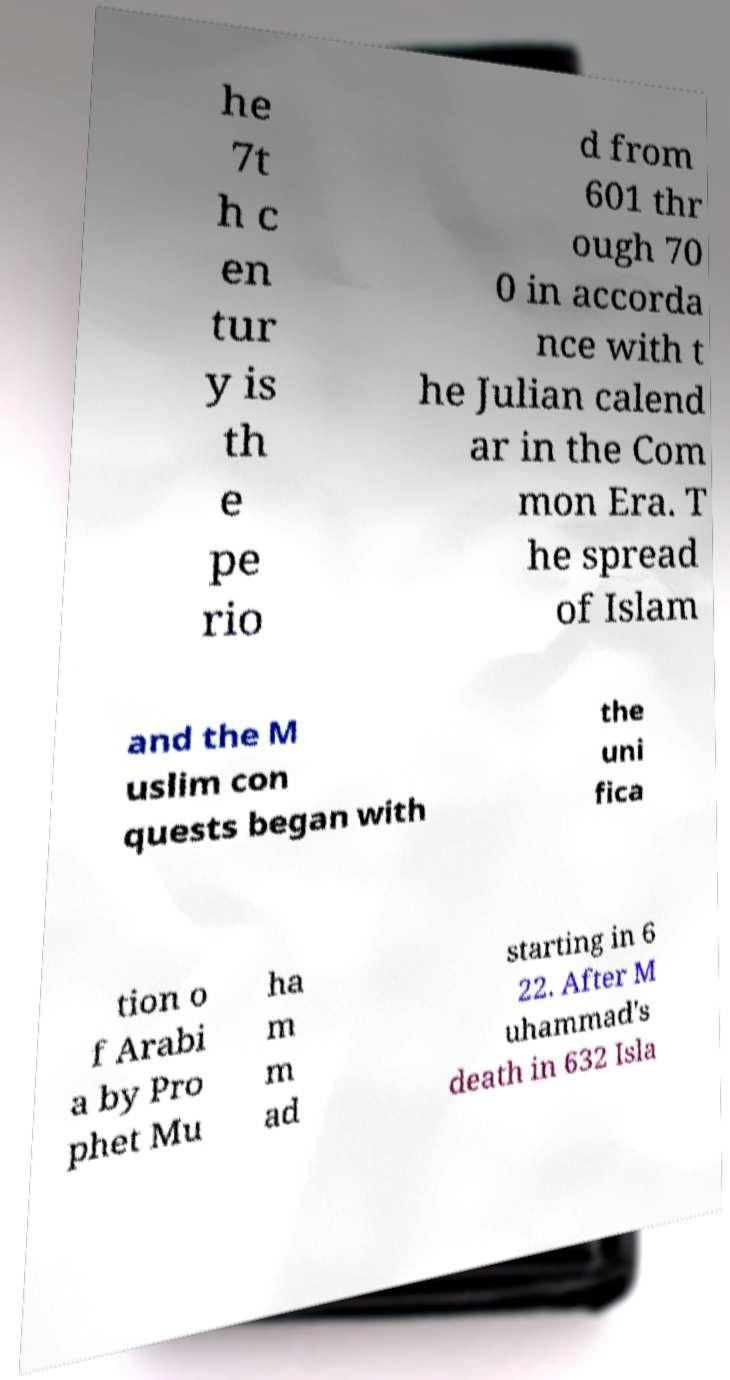Could you extract and type out the text from this image? he 7t h c en tur y is th e pe rio d from 601 thr ough 70 0 in accorda nce with t he Julian calend ar in the Com mon Era. T he spread of Islam and the M uslim con quests began with the uni fica tion o f Arabi a by Pro phet Mu ha m m ad starting in 6 22. After M uhammad's death in 632 Isla 